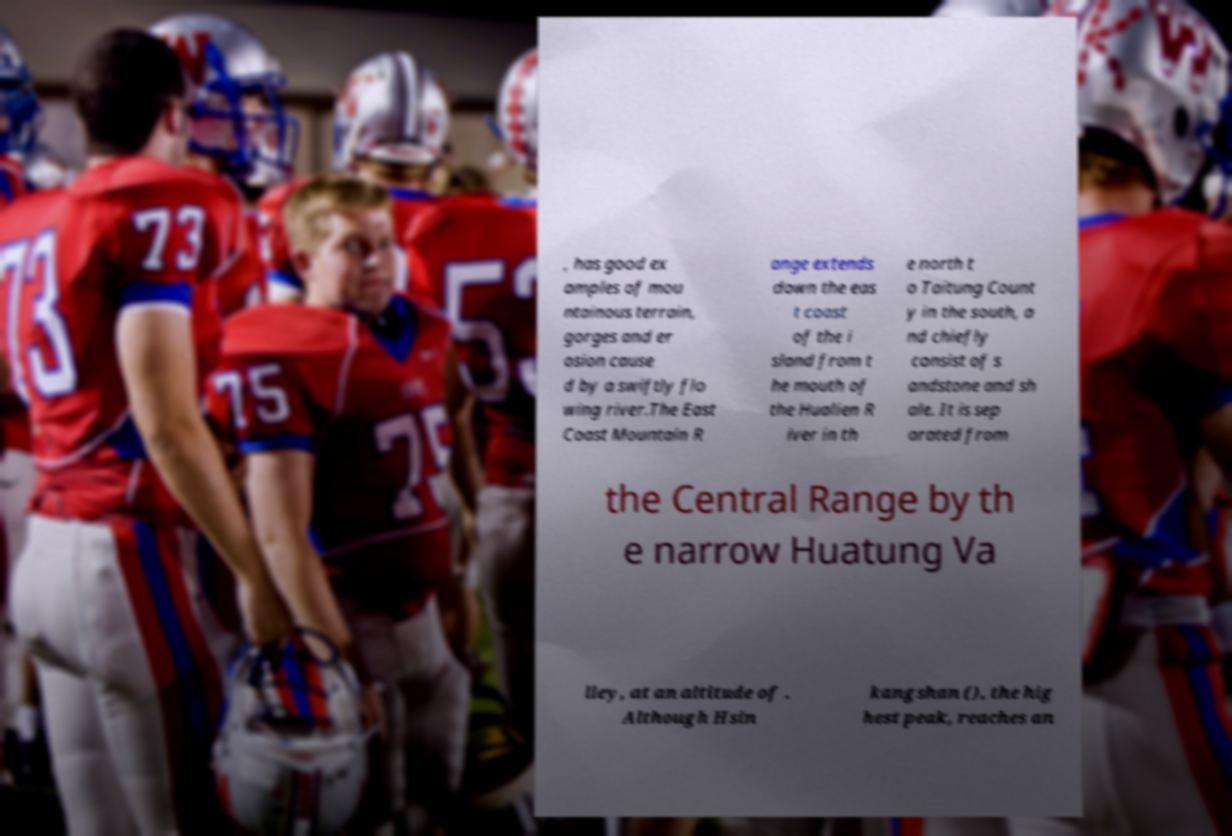There's text embedded in this image that I need extracted. Can you transcribe it verbatim? , has good ex amples of mou ntainous terrain, gorges and er osion cause d by a swiftly flo wing river.The East Coast Mountain R ange extends down the eas t coast of the i sland from t he mouth of the Hualien R iver in th e north t o Taitung Count y in the south, a nd chiefly consist of s andstone and sh ale. It is sep arated from the Central Range by th e narrow Huatung Va lley, at an altitude of . Although Hsin kangshan (), the hig hest peak, reaches an 